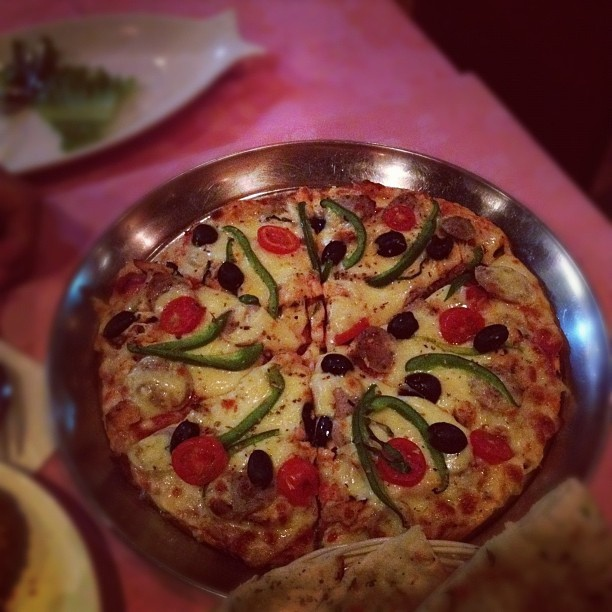Describe the objects in this image and their specific colors. I can see dining table in maroon, black, and brown tones and pizza in brown, maroon, black, and gray tones in this image. 